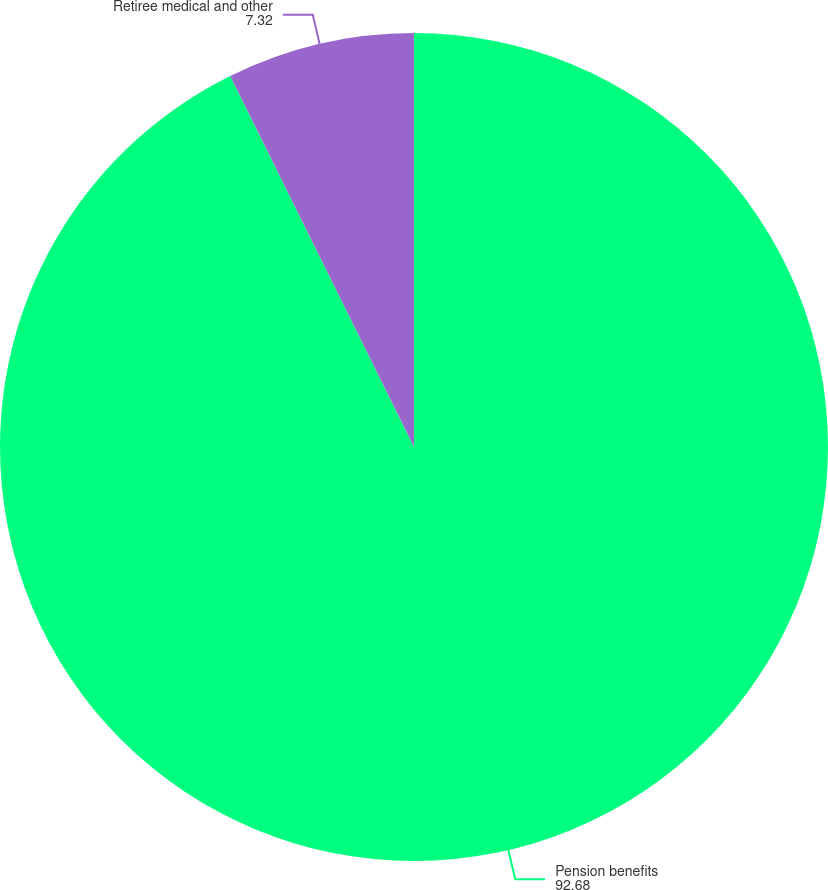Convert chart to OTSL. <chart><loc_0><loc_0><loc_500><loc_500><pie_chart><fcel>Pension benefits<fcel>Retiree medical and other<nl><fcel>92.68%<fcel>7.32%<nl></chart> 